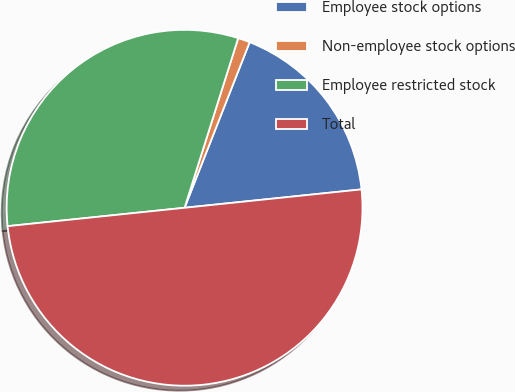Convert chart to OTSL. <chart><loc_0><loc_0><loc_500><loc_500><pie_chart><fcel>Employee stock options<fcel>Non-employee stock options<fcel>Employee restricted stock<fcel>Total<nl><fcel>17.39%<fcel>1.09%<fcel>31.52%<fcel>50.0%<nl></chart> 